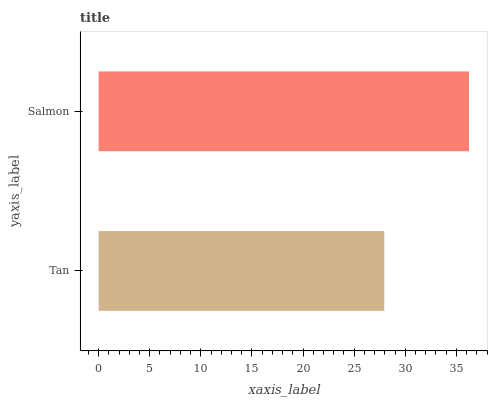Is Tan the minimum?
Answer yes or no. Yes. Is Salmon the maximum?
Answer yes or no. Yes. Is Salmon the minimum?
Answer yes or no. No. Is Salmon greater than Tan?
Answer yes or no. Yes. Is Tan less than Salmon?
Answer yes or no. Yes. Is Tan greater than Salmon?
Answer yes or no. No. Is Salmon less than Tan?
Answer yes or no. No. Is Salmon the high median?
Answer yes or no. Yes. Is Tan the low median?
Answer yes or no. Yes. Is Tan the high median?
Answer yes or no. No. Is Salmon the low median?
Answer yes or no. No. 